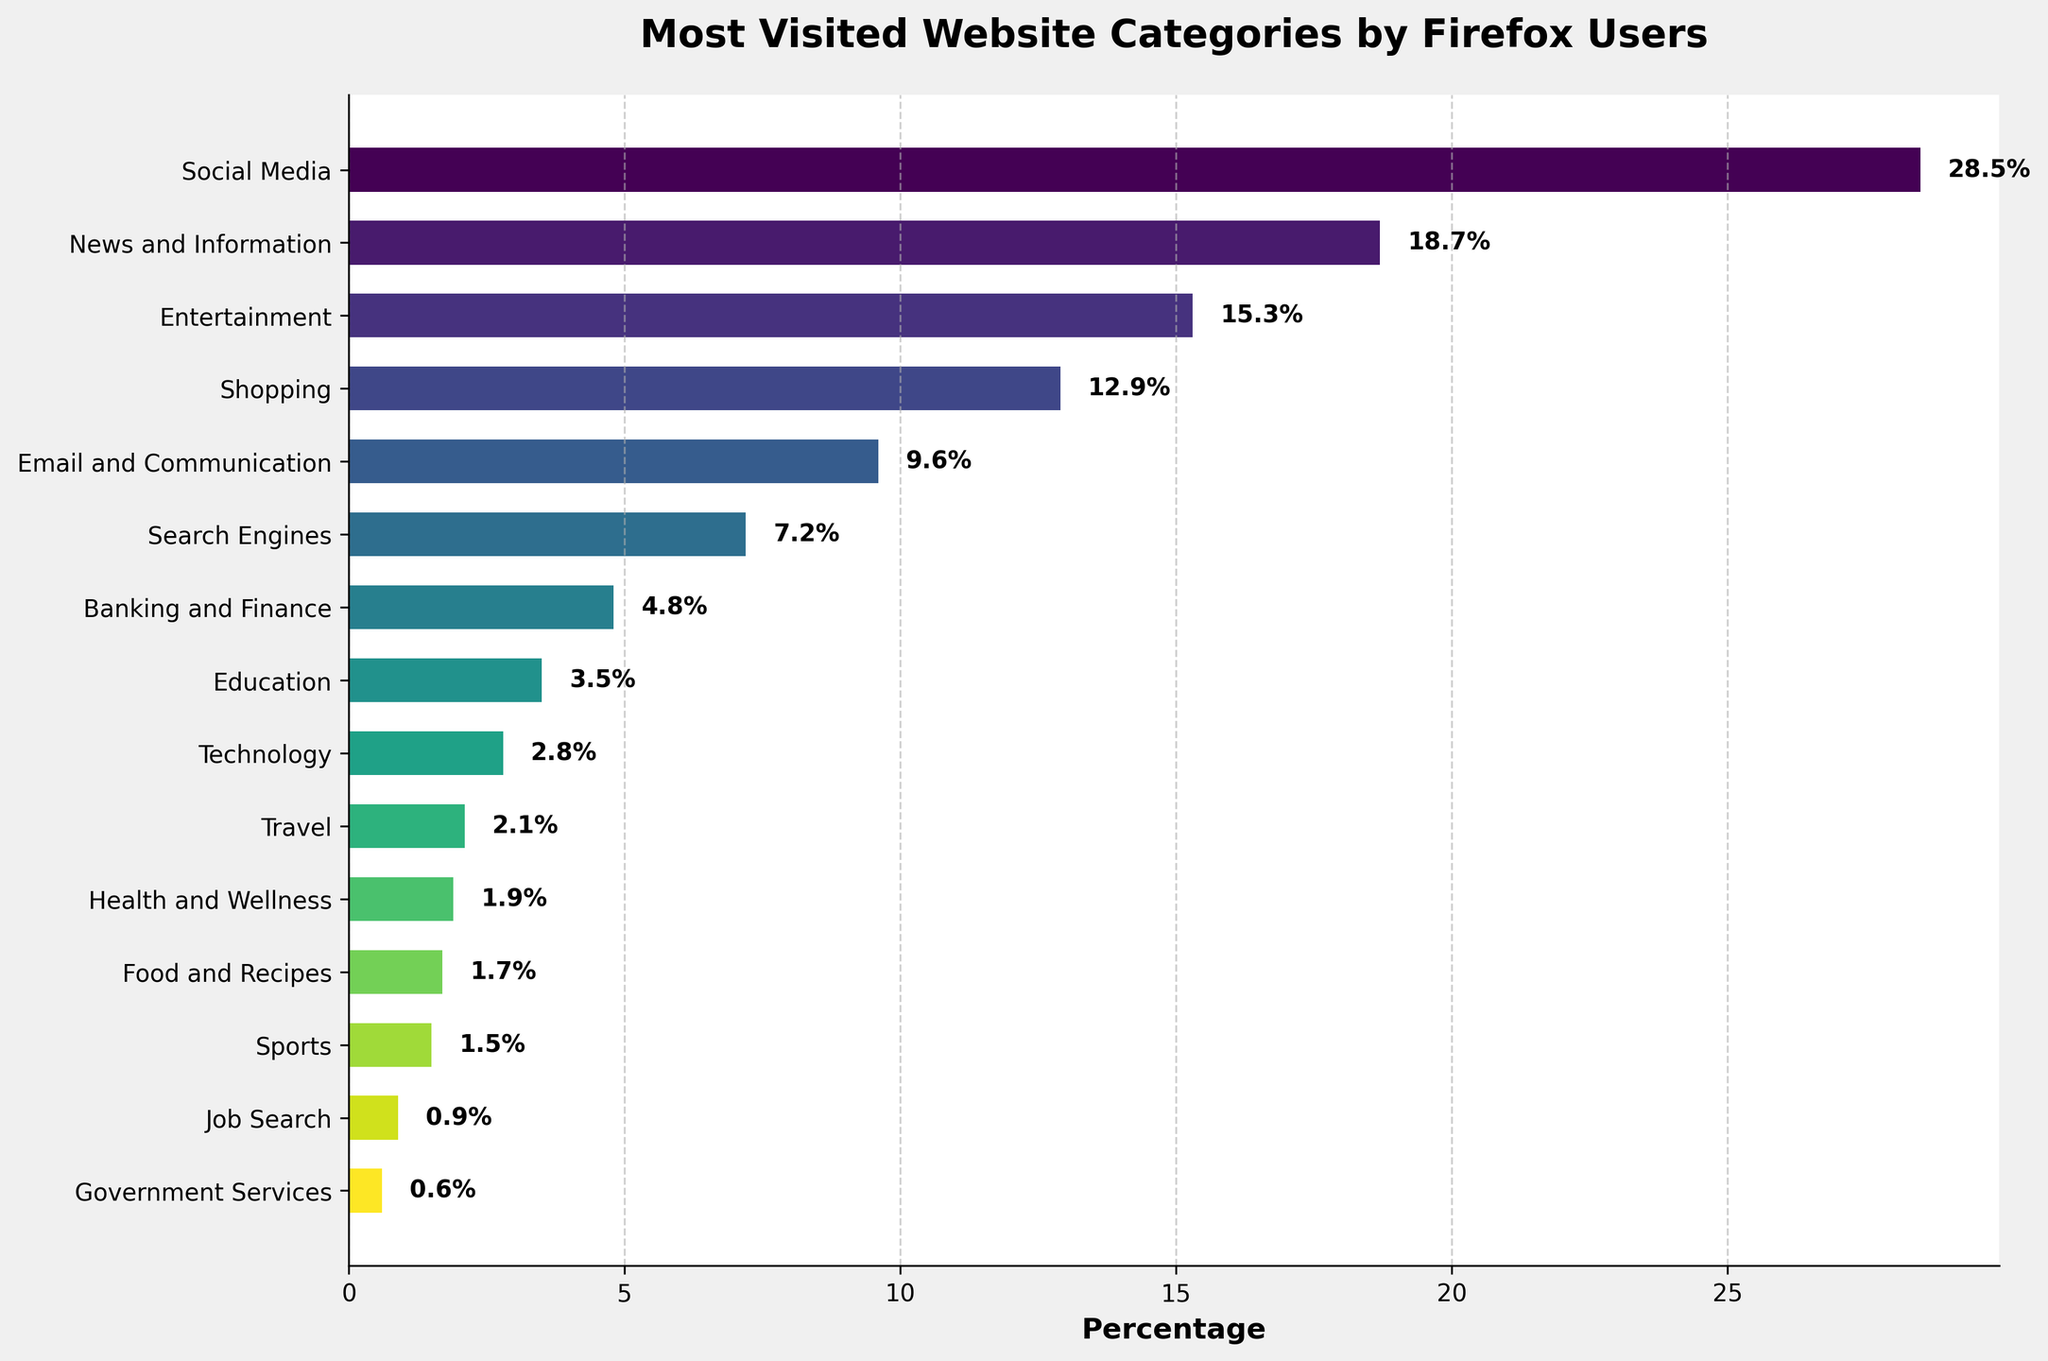Which website category is the most visited by Firefox users? The figure shows the categories on the y-axis and their corresponding percentages on the x-axis. The bar corresponding to "Social Media" is the longest, indicating it is the most visited category.
Answer: Social Media What is the combined percentage of visits for News and Information and Entertainment? From the figure, News and Information has a percentage of 18.7% and Entertainment has a percentage of 15.3%. Adding these, we get 18.7% + 15.3% = 34%.
Answer: 34% Which category has a higher percentage of visits: Shopping or Email and Communication? The figure shows Shopping with a percentage of 12.9% and Email and Communication with a percentage of 9.6%. Comparing these, 12.9% is higher than 9.6%.
Answer: Shopping By how much does the Social Media category exceed the Banking and Finance category in terms of visit percentage? Social Media has a visit percentage of 28.5% and Banking and Finance has 4.8%. The difference is 28.5% - 4.8% = 23.7%.
Answer: 23.7% What is the percentage difference between the top two visited categories? The top two categories are Social Media (28.5%) and News and Information (18.7%). The difference is 28.5% - 18.7% = 9.8%.
Answer: 9.8% What is the ratio of visits of the Technology category to the Travel category? The Technology category has a visit percentage of 2.8% and the Travel category has 2.1%. The ratio is 2.8% / 2.1% ≈ 1.33.
Answer: 1.33 How many categories have a percentage of visits greater than 10%? In the figure, Social Media (28.5%), News and Information (18.7%), Entertainment (15.3%), and Shopping (12.9%) all have percentages greater than 10%. There are 4 categories.
Answer: 4 If the percentage of visits for Sports doubled, what would it be? The current percentage for Sports is 1.5%. If it doubled, it would be 1.5% * 2 = 3%.
Answer: 3% Which category has the smallest percentage of visits, and what is its percentage? The figure reveals that Government Services has the smallest percentage of visits at 0.6%.
Answer: Government Services, 0.6% What is the overall percentage of visits for categories with less than 5% each? Adding the categories with less than 5%: Banking and Finance (4.8%), Education (3.5%), Technology (2.8%), Travel (2.1%), Health and Wellness (1.9%), Food and Recipes (1.7%), Sports (1.5%), Job Search (0.9%), Government Services (0.6%), we get 4.8% + 3.5% + 2.8% + 2.1% + 1.9% + 1.7% + 1.5% + 0.9% + 0.6% = 19.8%.
Answer: 19.8% 